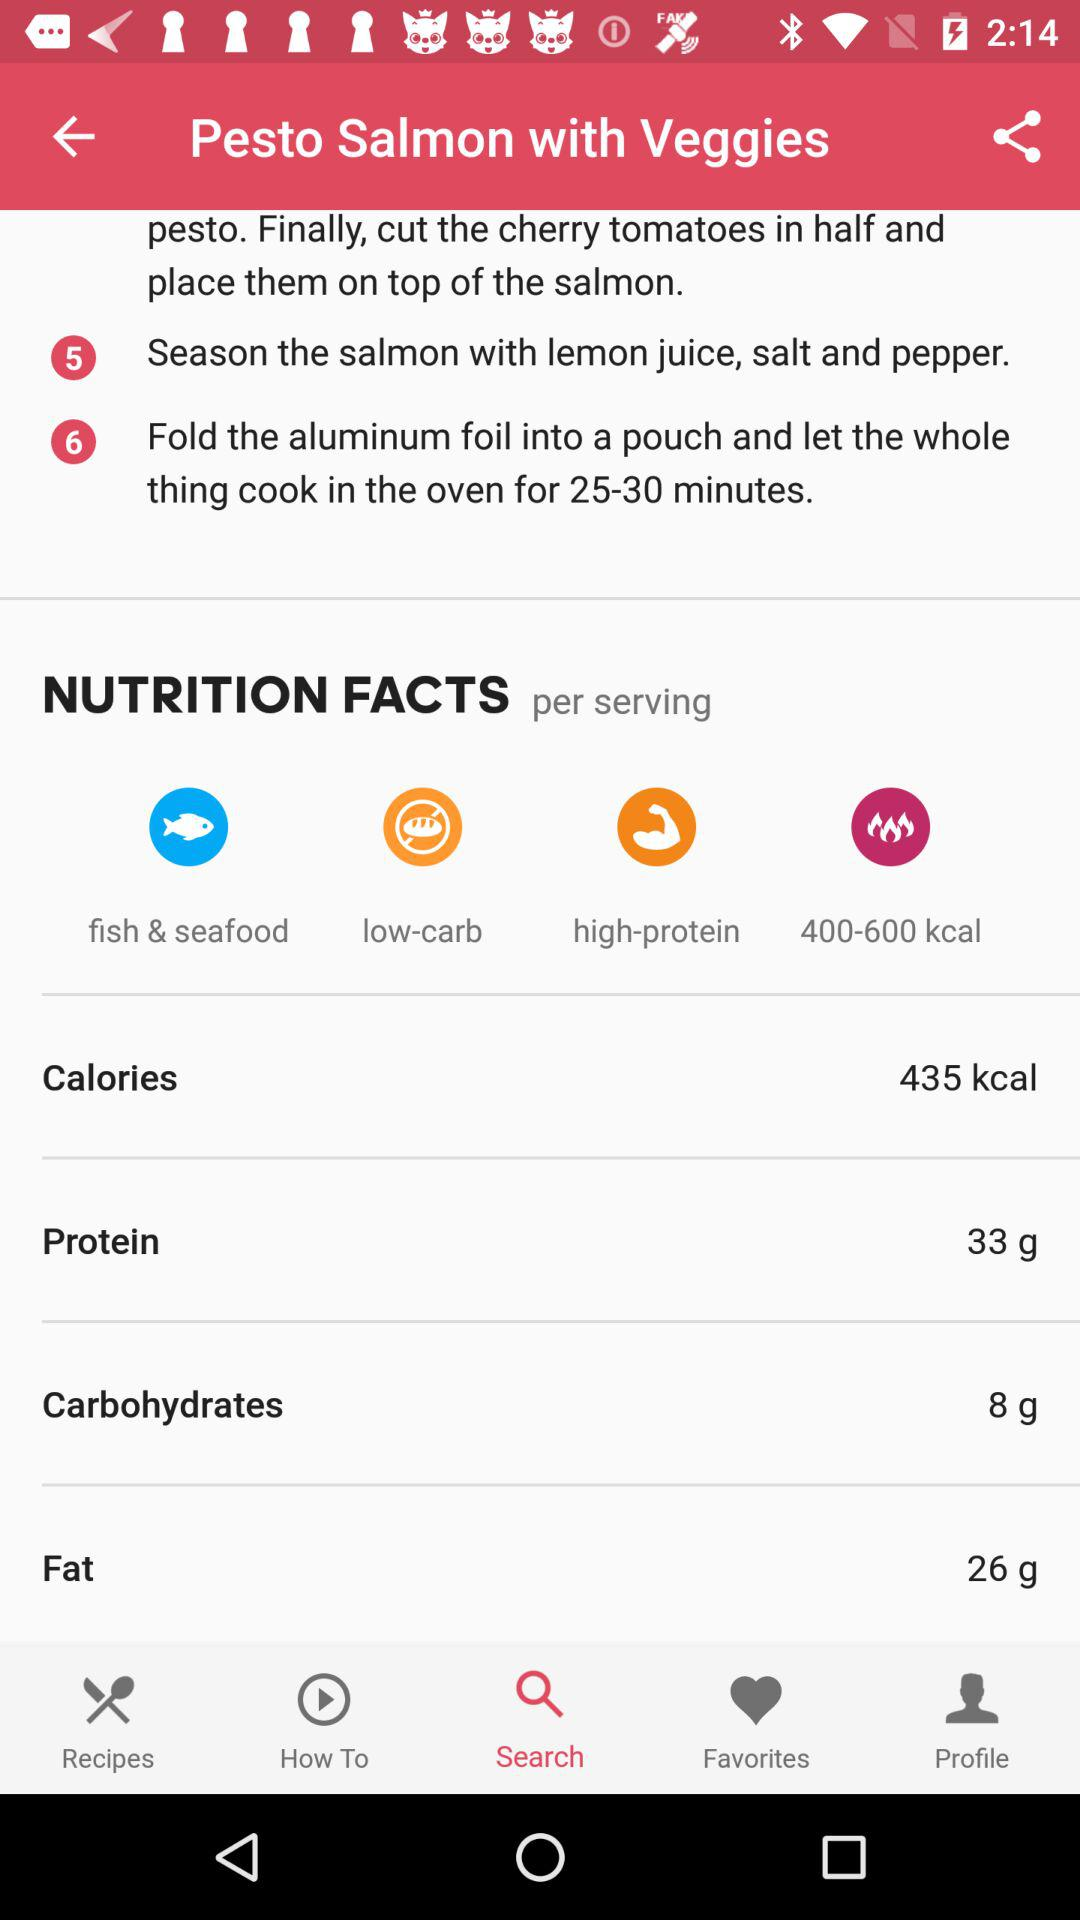How many grams of protein are in a serving of this recipe?
Answer the question using a single word or phrase. 33 g 